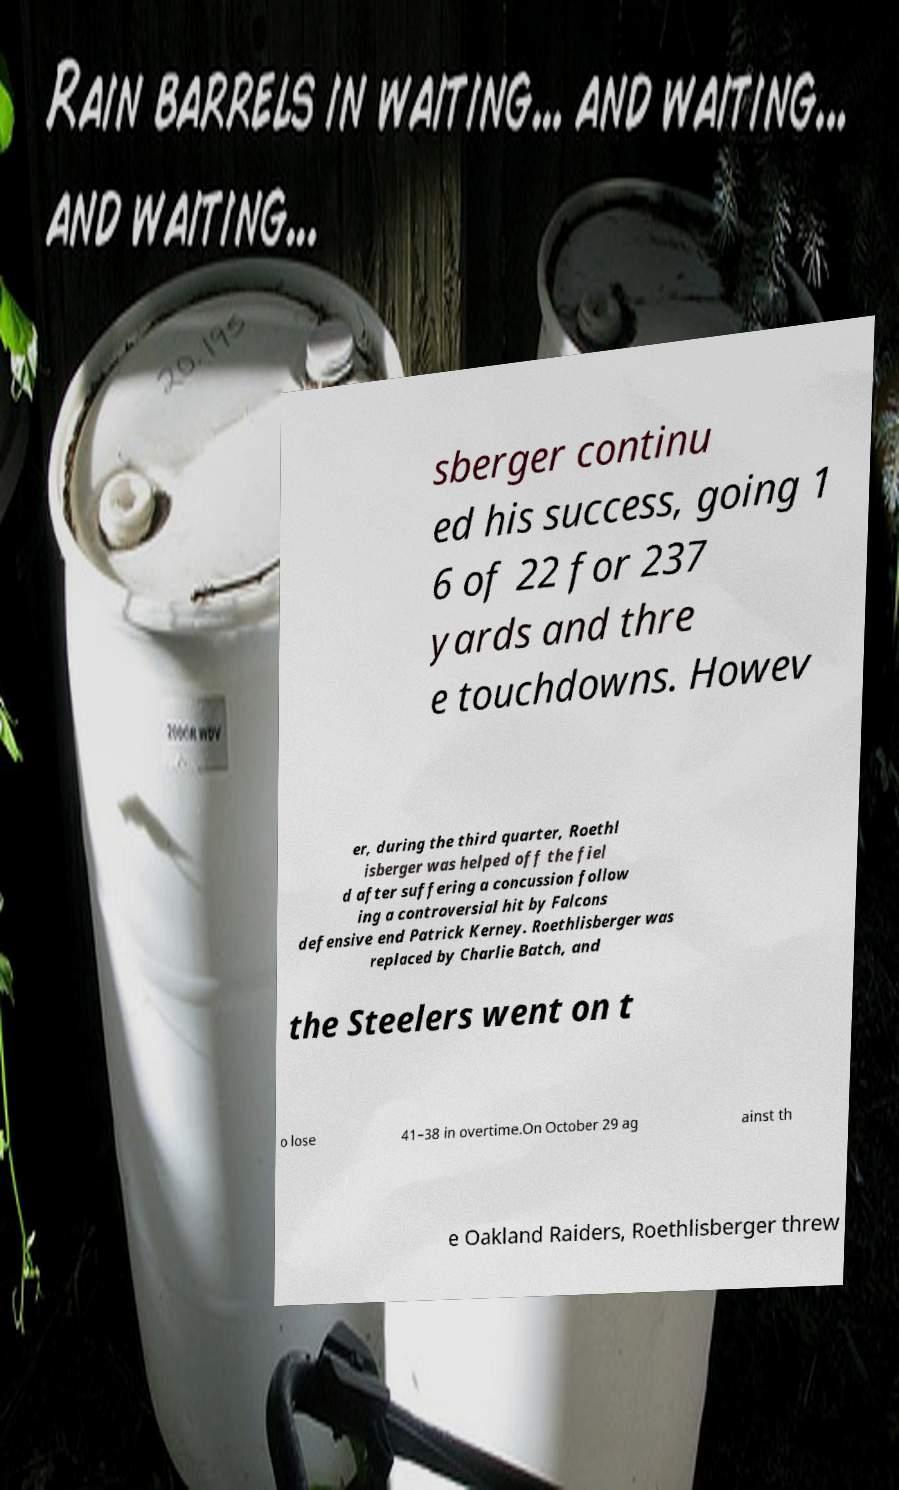Can you accurately transcribe the text from the provided image for me? sberger continu ed his success, going 1 6 of 22 for 237 yards and thre e touchdowns. Howev er, during the third quarter, Roethl isberger was helped off the fiel d after suffering a concussion follow ing a controversial hit by Falcons defensive end Patrick Kerney. Roethlisberger was replaced by Charlie Batch, and the Steelers went on t o lose 41–38 in overtime.On October 29 ag ainst th e Oakland Raiders, Roethlisberger threw 